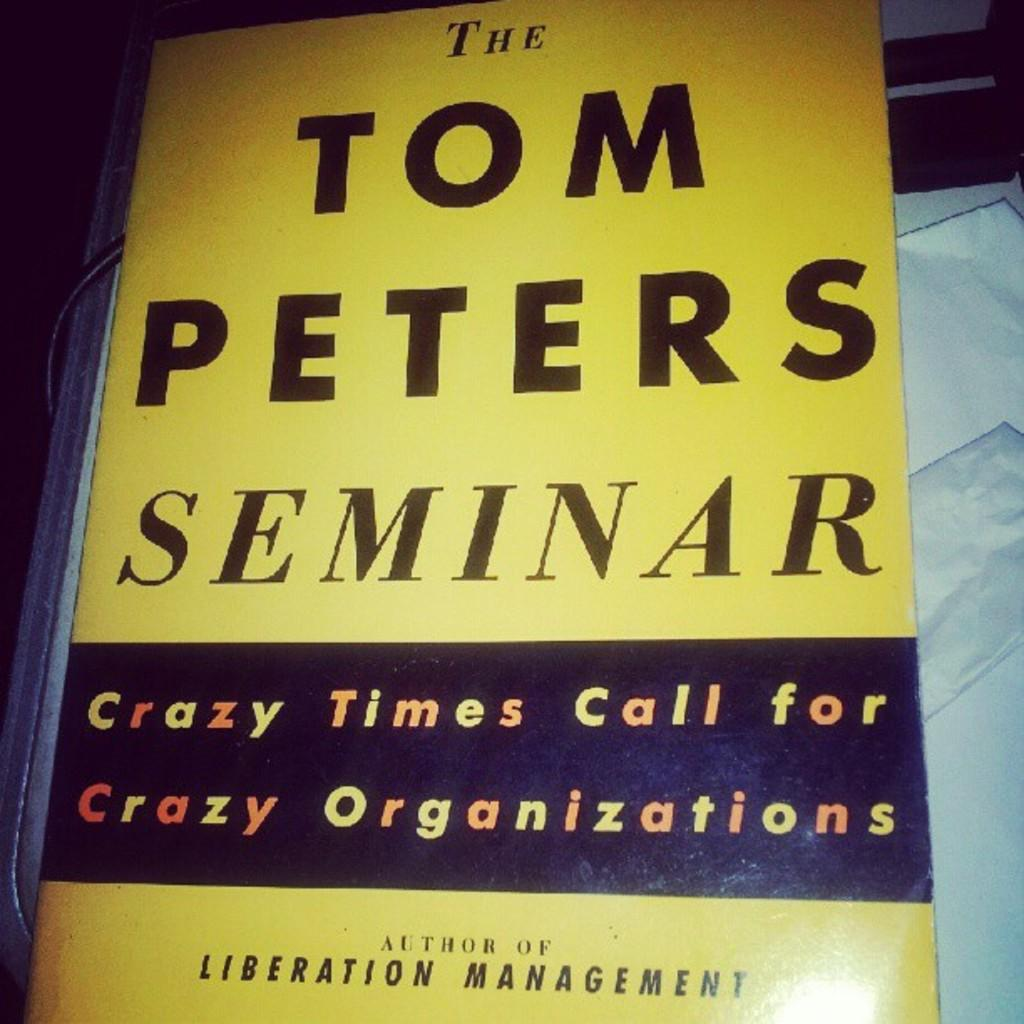Provide a one-sentence caption for the provided image. A book or poster that says The Tom Peters Seminar, Crazy Times Call for Crazy Organizations. 